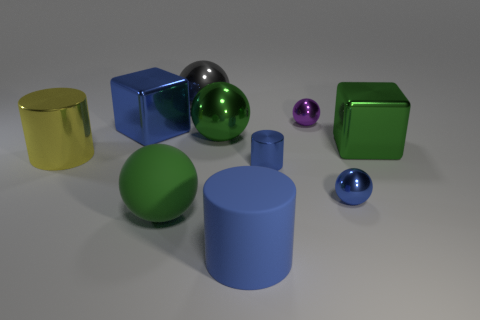There is a tiny shiny object that is the same color as the tiny cylinder; what is its shape?
Keep it short and to the point. Sphere. Is the color of the tiny metallic cylinder the same as the large rubber cylinder?
Keep it short and to the point. Yes. Does the large blue cube have the same material as the big gray ball?
Make the answer very short. Yes. How many things are either big balls or blue matte cylinders?
Your answer should be very brief. 4. What size is the blue metallic cylinder?
Offer a very short reply. Small. Is the number of small blue shiny cylinders less than the number of small red rubber cylinders?
Offer a terse response. No. How many cubes have the same color as the rubber cylinder?
Keep it short and to the point. 1. Does the small shiny thing that is in front of the small blue metal cylinder have the same color as the small cylinder?
Your answer should be very brief. Yes. What is the shape of the large blue thing that is to the left of the matte sphere?
Provide a succinct answer. Cube. There is a green thing that is right of the small cylinder; are there any balls that are in front of it?
Give a very brief answer. Yes. 